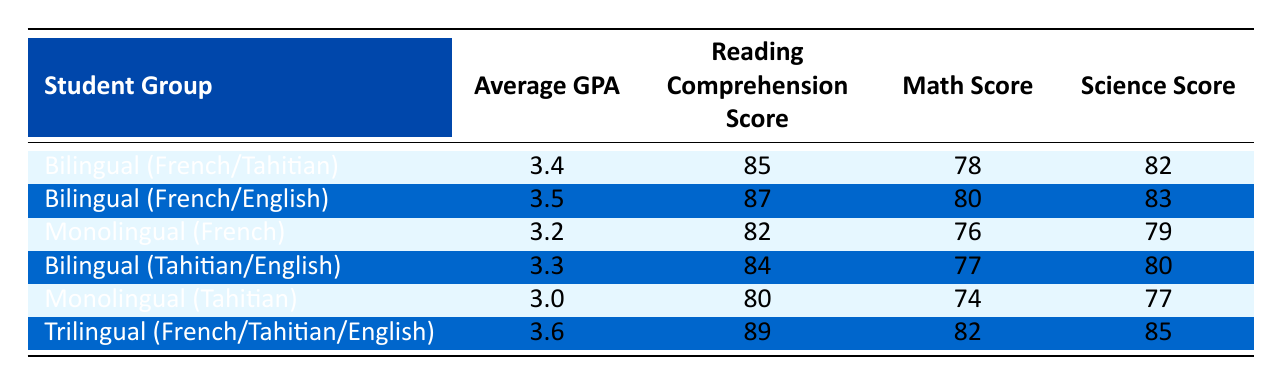What is the average GPA for bilingual (French/English) students? The table shows that the average GPA for bilingual (French/English) students is listed under that category as 3.5.
Answer: 3.5 Which student group has the highest average GPA? By comparing the average GPA values in the table, the trilingual (French/Tahitian/English) group has the highest GPA at 3.6.
Answer: 3.6 What is the reading comprehension score of monolingual (Tahitian) students? The table displays the reading comprehension score for monolingual (Tahitian) students as 80.
Answer: 80 Is the average math score of bilingual (Tahitian/English) students higher than that of monolingual (French) students? The average math score for bilingual (Tahitian/English) students is 77, while for monolingual (French) students it is 76. Since 77 is greater than 76, the statement is true.
Answer: Yes What is the difference in average GPA between trilingual and bilingual (French/Tahitian) students? The average GPA for trilingual students is 3.6 and for bilingual (French/Tahitian) students it is 3.4. The difference is calculated as 3.6 - 3.4 = 0.2.
Answer: 0.2 Which group has the highest reading comprehension score and what is that score? By looking at the table, the group with the highest reading comprehension score is Trilingual (French/Tahitian/English) with a score of 89.
Answer: 89 Calculate the average science score for bilingual (French/Tahitian) and bilingual (French/English) students. The science scores for bilingual (French/Tahitian) is 82 and for bilingual (French/English) is 83. The average is (82 + 83) / 2 = 82.5.
Answer: 82.5 Are bilingual (French/English) students performing better in reading comprehension than all monolingual students? Bilingual (French/English) students have a reading comprehension score of 87. Monolingual (French) students score 82, and monolingual (Tahitian) students score 80. Since 87 is higher than both, the answer is yes.
Answer: Yes 